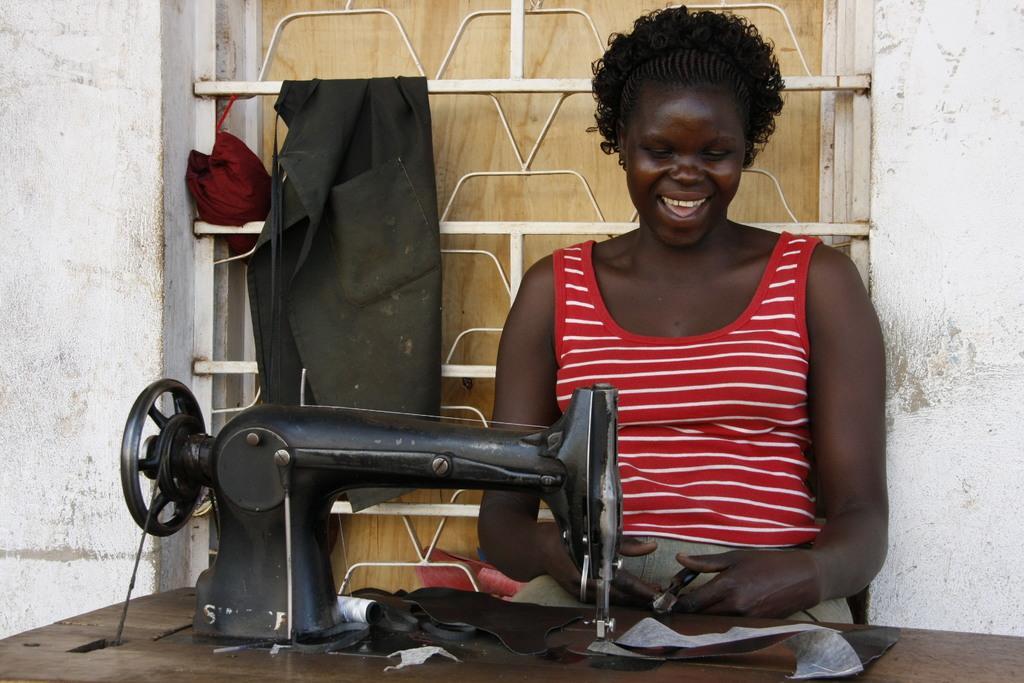Can you describe this image briefly? In this picture there is a women who is wearing t-shirt and sitting on the chair, beside her we can see the cloth machine. In the bank we can see the window, steel pipes and some clothes are hanging on it. 